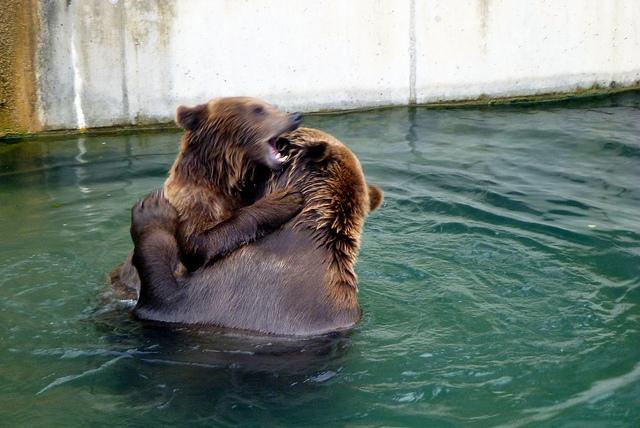Are the bears fighting?
Keep it brief. Yes. What type of animal is this?
Short answer required. Bear. What kind of animals are these?
Give a very brief answer. Bears. Are the bears the same size?
Short answer required. Yes. Are what the bears doing dangerous?
Short answer required. No. What are the bears in?
Concise answer only. Water. 